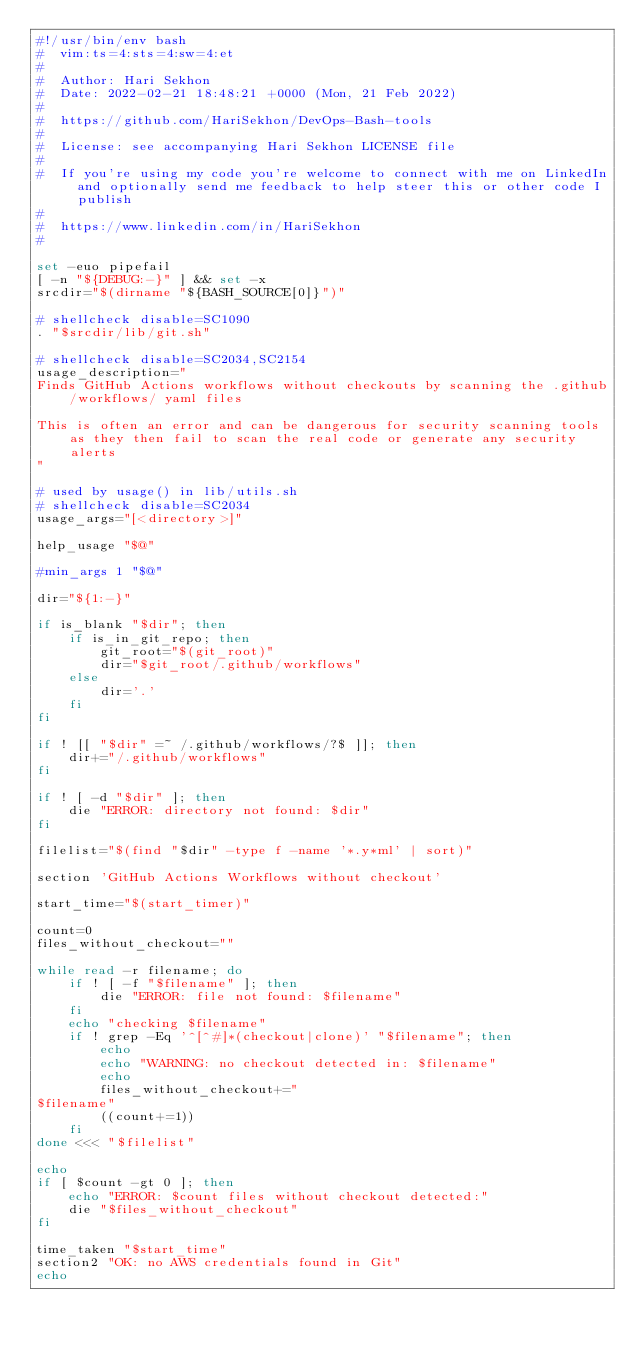Convert code to text. <code><loc_0><loc_0><loc_500><loc_500><_Bash_>#!/usr/bin/env bash
#  vim:ts=4:sts=4:sw=4:et
#
#  Author: Hari Sekhon
#  Date: 2022-02-21 18:48:21 +0000 (Mon, 21 Feb 2022)
#
#  https://github.com/HariSekhon/DevOps-Bash-tools
#
#  License: see accompanying Hari Sekhon LICENSE file
#
#  If you're using my code you're welcome to connect with me on LinkedIn and optionally send me feedback to help steer this or other code I publish
#
#  https://www.linkedin.com/in/HariSekhon
#

set -euo pipefail
[ -n "${DEBUG:-}" ] && set -x
srcdir="$(dirname "${BASH_SOURCE[0]}")"

# shellcheck disable=SC1090
. "$srcdir/lib/git.sh"

# shellcheck disable=SC2034,SC2154
usage_description="
Finds GitHub Actions workflows without checkouts by scanning the .github/workflows/ yaml files

This is often an error and can be dangerous for security scanning tools as they then fail to scan the real code or generate any security alerts
"

# used by usage() in lib/utils.sh
# shellcheck disable=SC2034
usage_args="[<directory>]"

help_usage "$@"

#min_args 1 "$@"

dir="${1:-}"

if is_blank "$dir"; then
    if is_in_git_repo; then
        git_root="$(git_root)"
        dir="$git_root/.github/workflows"
    else
        dir='.'
    fi
fi

if ! [[ "$dir" =~ /.github/workflows/?$ ]]; then
    dir+="/.github/workflows"
fi

if ! [ -d "$dir" ]; then
    die "ERROR: directory not found: $dir"
fi

filelist="$(find "$dir" -type f -name '*.y*ml' | sort)"

section 'GitHub Actions Workflows without checkout'

start_time="$(start_timer)"

count=0
files_without_checkout=""

while read -r filename; do
    if ! [ -f "$filename" ]; then
        die "ERROR: file not found: $filename"
    fi
    echo "checking $filename"
    if ! grep -Eq '^[^#]*(checkout|clone)' "$filename"; then
        echo
        echo "WARNING: no checkout detected in: $filename"
        echo
        files_without_checkout+="
$filename"
        ((count+=1))
    fi
done <<< "$filelist"

echo
if [ $count -gt 0 ]; then
    echo "ERROR: $count files without checkout detected:"
    die "$files_without_checkout"
fi

time_taken "$start_time"
section2 "OK: no AWS credentials found in Git"
echo
</code> 